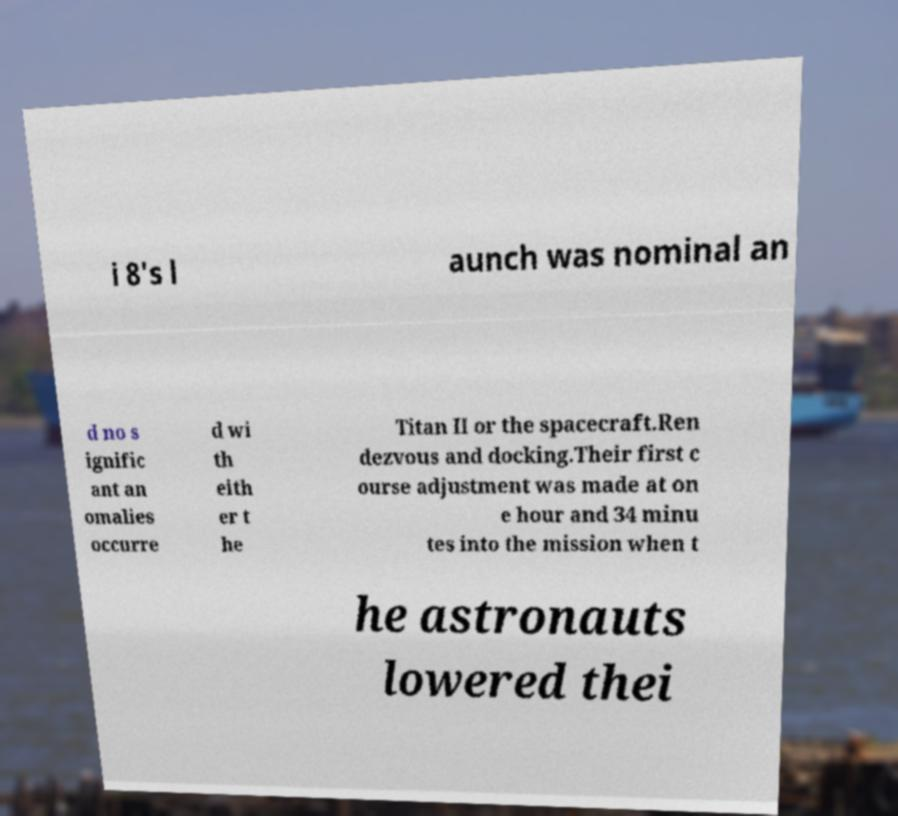What messages or text are displayed in this image? I need them in a readable, typed format. i 8's l aunch was nominal an d no s ignific ant an omalies occurre d wi th eith er t he Titan II or the spacecraft.Ren dezvous and docking.Their first c ourse adjustment was made at on e hour and 34 minu tes into the mission when t he astronauts lowered thei 